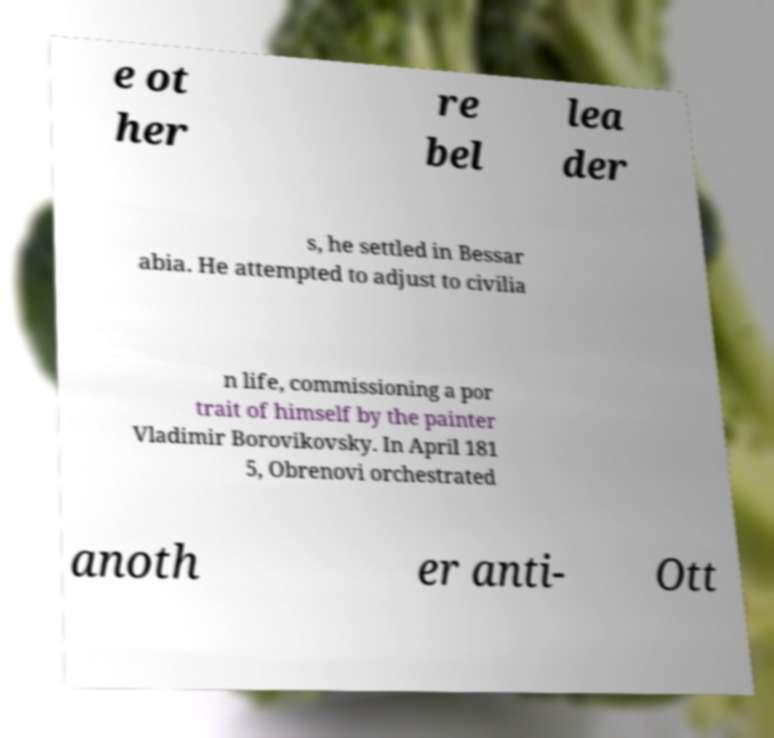For documentation purposes, I need the text within this image transcribed. Could you provide that? e ot her re bel lea der s, he settled in Bessar abia. He attempted to adjust to civilia n life, commissioning a por trait of himself by the painter Vladimir Borovikovsky. In April 181 5, Obrenovi orchestrated anoth er anti- Ott 